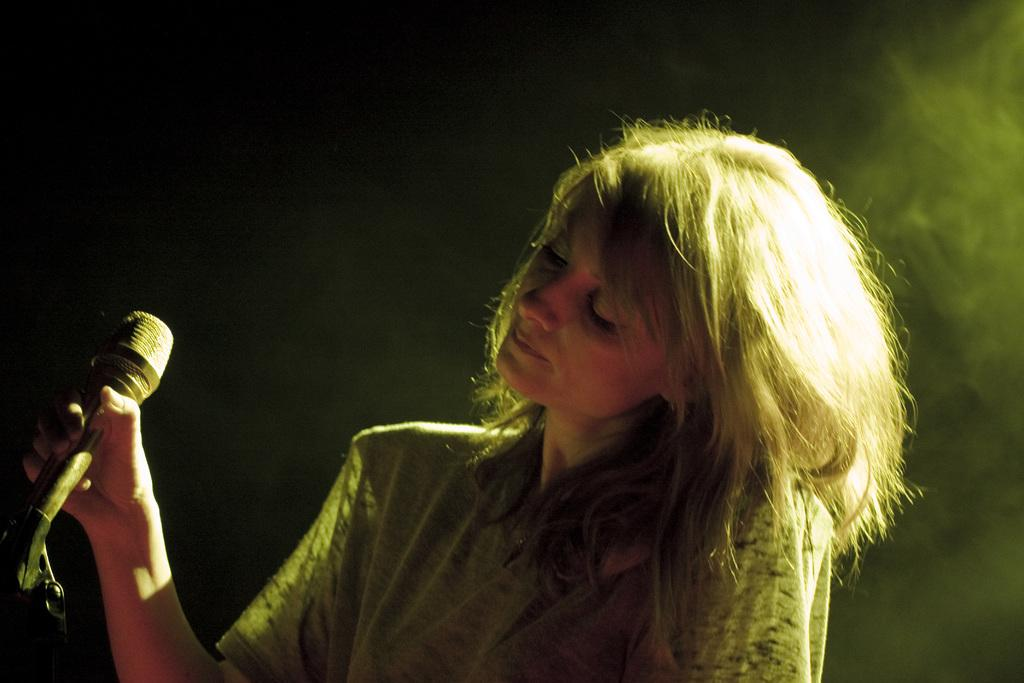What is the main subject of the image? The main subject of the image is a woman. What is the woman holding in the image? The woman is holding a microphone. What type of dirt can be seen on the woman's shoes in the image? There is no dirt visible on the woman's shoes in the image, as the provided facts do not mention any dirt or shoes. 